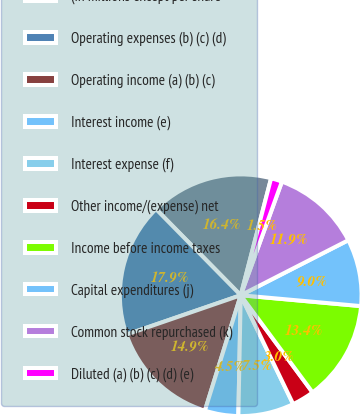Convert chart to OTSL. <chart><loc_0><loc_0><loc_500><loc_500><pie_chart><fcel>(in millions except per share<fcel>Operating expenses (b) (c) (d)<fcel>Operating income (a) (b) (c)<fcel>Interest income (e)<fcel>Interest expense (f)<fcel>Other income/(expense) net<fcel>Income before income taxes<fcel>Capital expenditures (j)<fcel>Common stock repurchased (k)<fcel>Diluted (a) (b) (c) (d) (e)<nl><fcel>16.42%<fcel>17.91%<fcel>14.93%<fcel>4.48%<fcel>7.46%<fcel>2.99%<fcel>13.43%<fcel>8.96%<fcel>11.94%<fcel>1.49%<nl></chart> 